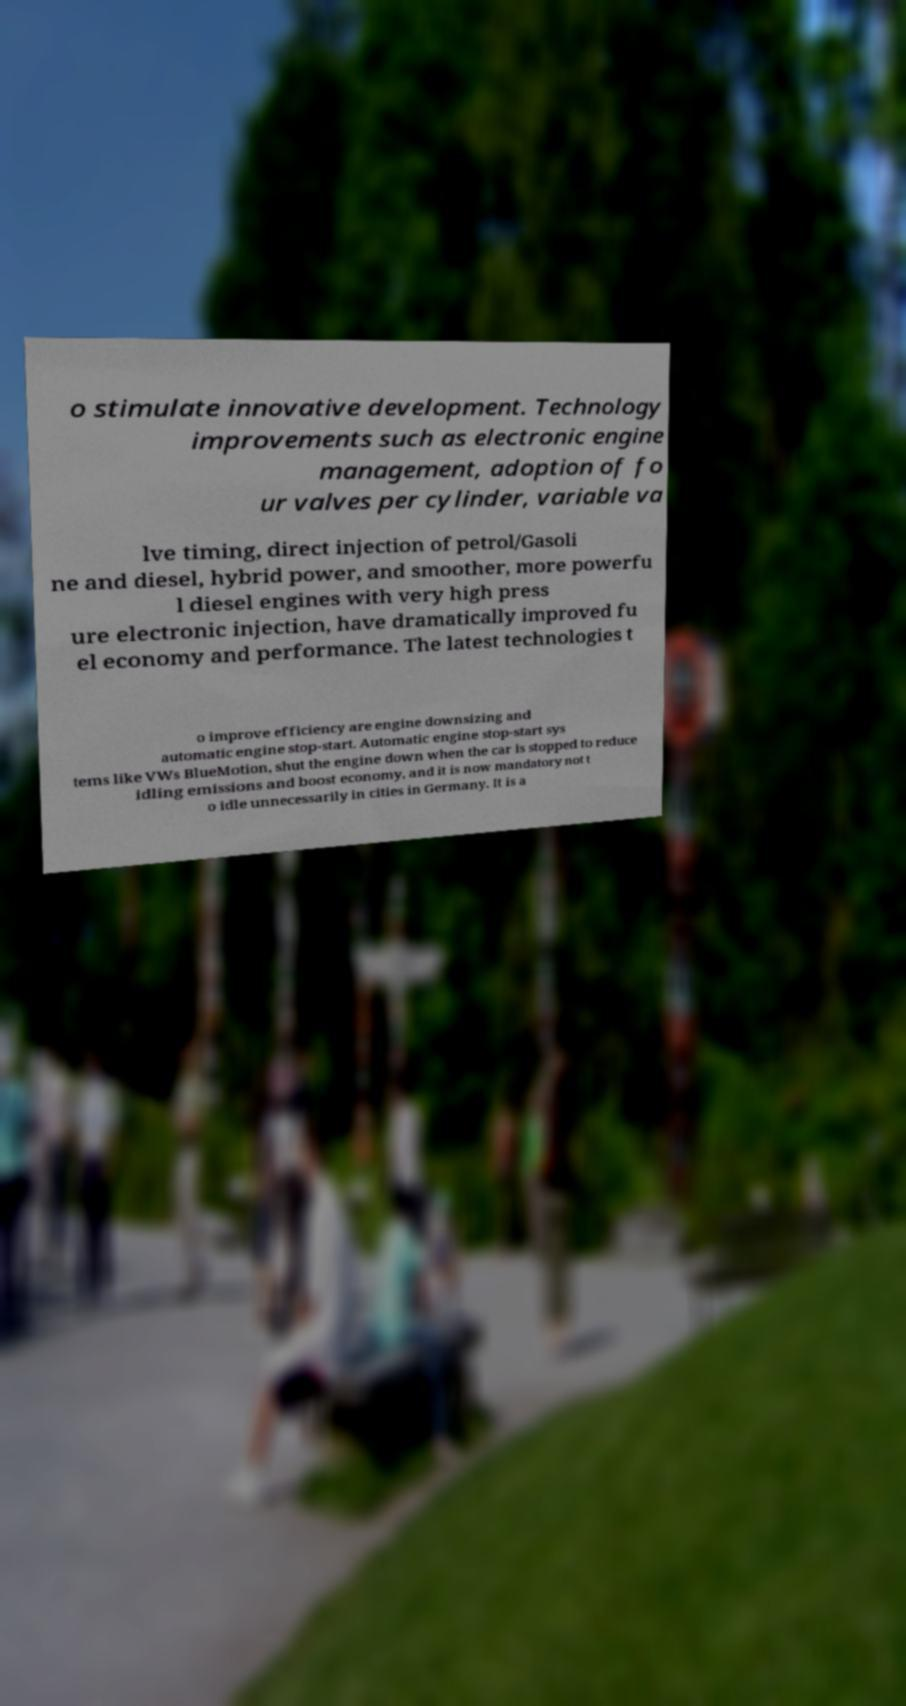Please read and relay the text visible in this image. What does it say? o stimulate innovative development. Technology improvements such as electronic engine management, adoption of fo ur valves per cylinder, variable va lve timing, direct injection of petrol/Gasoli ne and diesel, hybrid power, and smoother, more powerfu l diesel engines with very high press ure electronic injection, have dramatically improved fu el economy and performance. The latest technologies t o improve efficiency are engine downsizing and automatic engine stop-start. Automatic engine stop-start sys tems like VWs BlueMotion, shut the engine down when the car is stopped to reduce idling emissions and boost economy, and it is now mandatory not t o idle unnecessarily in cities in Germany. It is a 